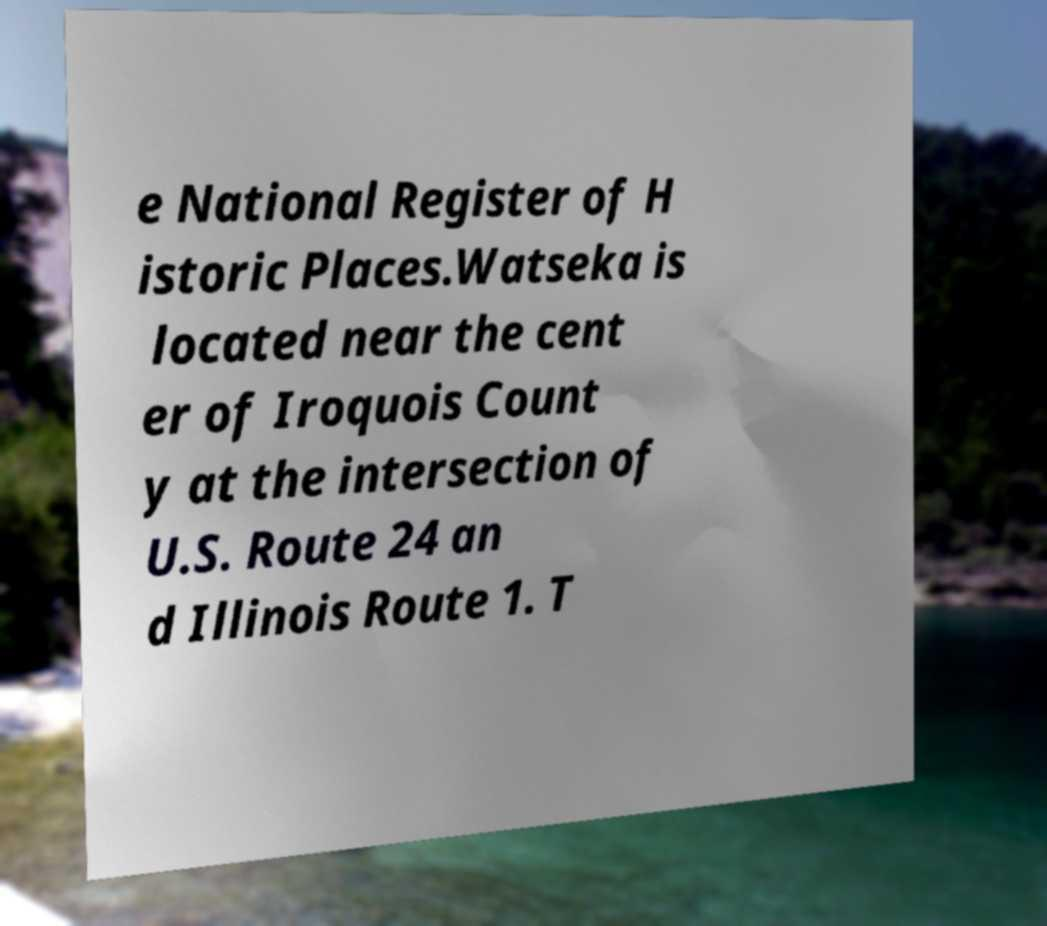Could you extract and type out the text from this image? e National Register of H istoric Places.Watseka is located near the cent er of Iroquois Count y at the intersection of U.S. Route 24 an d Illinois Route 1. T 